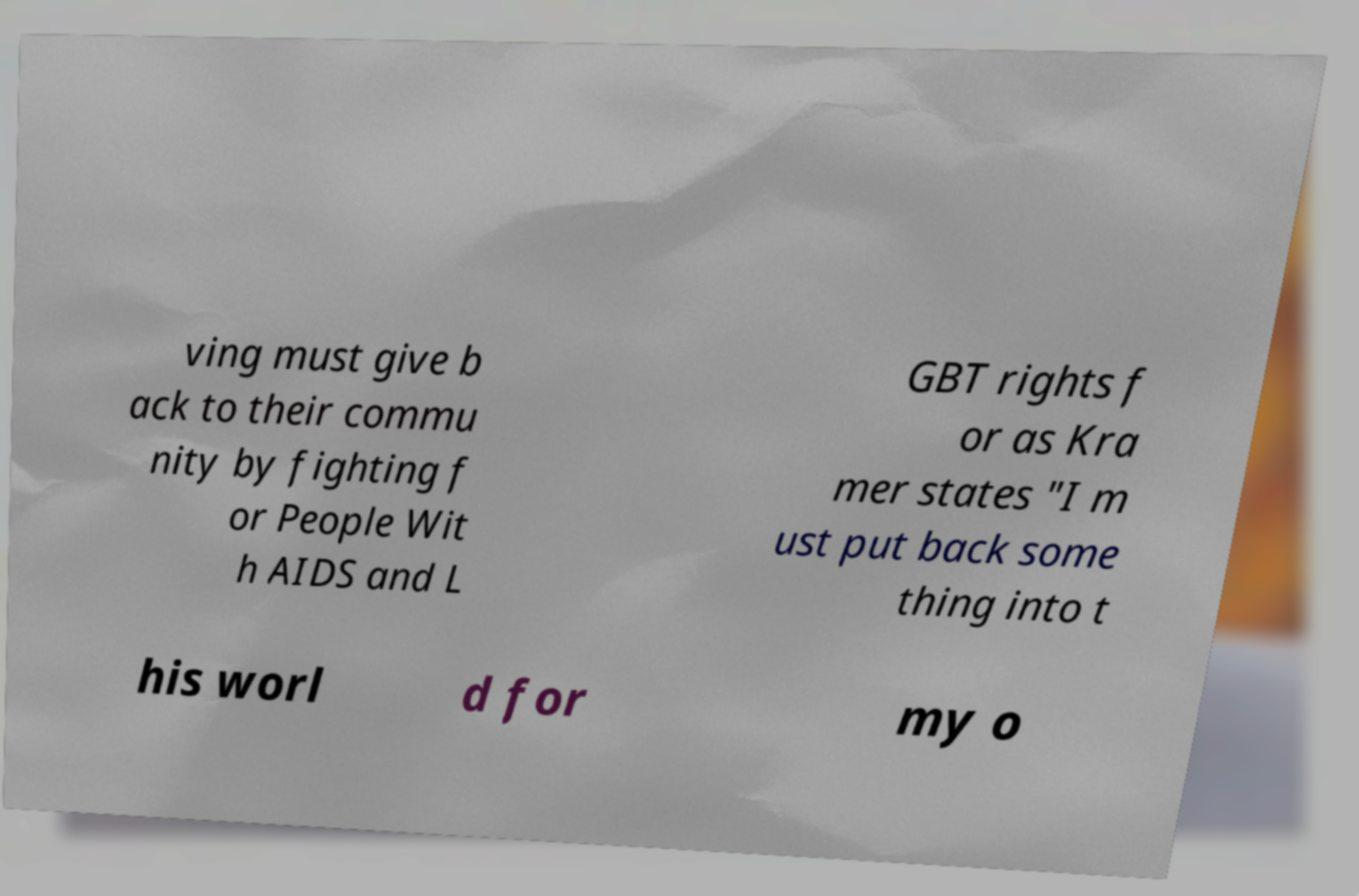For documentation purposes, I need the text within this image transcribed. Could you provide that? ving must give b ack to their commu nity by fighting f or People Wit h AIDS and L GBT rights f or as Kra mer states "I m ust put back some thing into t his worl d for my o 